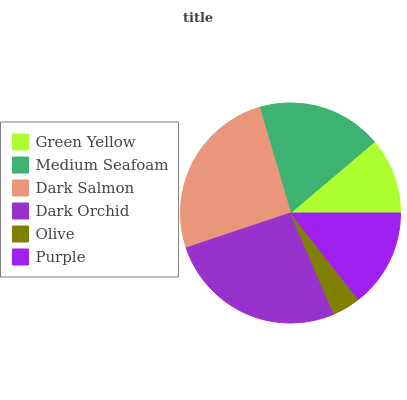Is Olive the minimum?
Answer yes or no. Yes. Is Dark Orchid the maximum?
Answer yes or no. Yes. Is Medium Seafoam the minimum?
Answer yes or no. No. Is Medium Seafoam the maximum?
Answer yes or no. No. Is Medium Seafoam greater than Green Yellow?
Answer yes or no. Yes. Is Green Yellow less than Medium Seafoam?
Answer yes or no. Yes. Is Green Yellow greater than Medium Seafoam?
Answer yes or no. No. Is Medium Seafoam less than Green Yellow?
Answer yes or no. No. Is Medium Seafoam the high median?
Answer yes or no. Yes. Is Purple the low median?
Answer yes or no. Yes. Is Dark Salmon the high median?
Answer yes or no. No. Is Dark Salmon the low median?
Answer yes or no. No. 